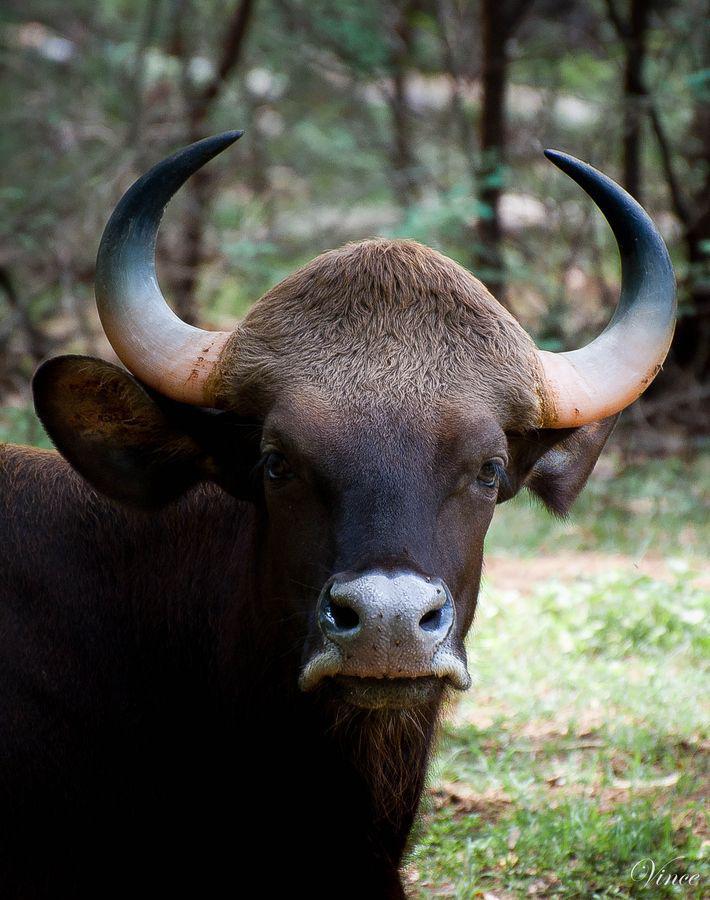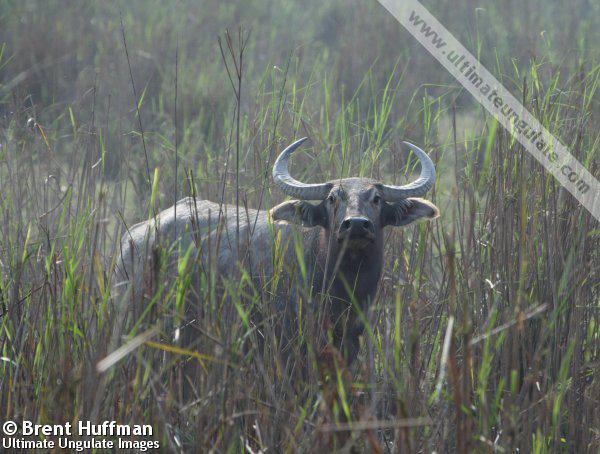The first image is the image on the left, the second image is the image on the right. Assess this claim about the two images: "There are three animals.". Correct or not? Answer yes or no. No. The first image is the image on the left, the second image is the image on the right. For the images displayed, is the sentence "Each image includes one water buffalo who is looking straight ahead at the camera and who does not have a rope strung in its nose." factually correct? Answer yes or no. Yes. 